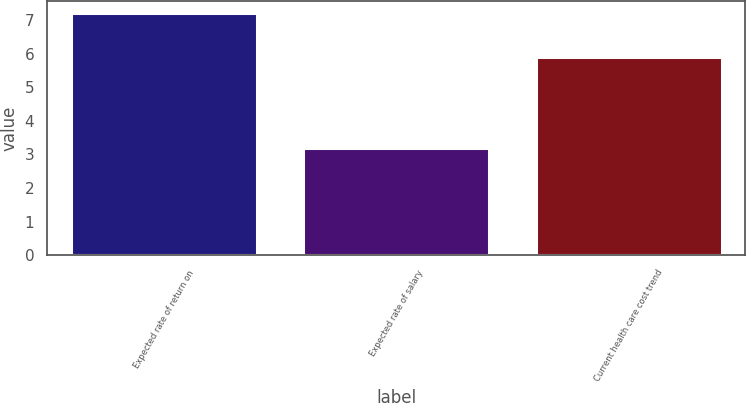Convert chart. <chart><loc_0><loc_0><loc_500><loc_500><bar_chart><fcel>Expected rate of return on<fcel>Expected rate of salary<fcel>Current health care cost trend<nl><fcel>7.2<fcel>3.2<fcel>5.9<nl></chart> 